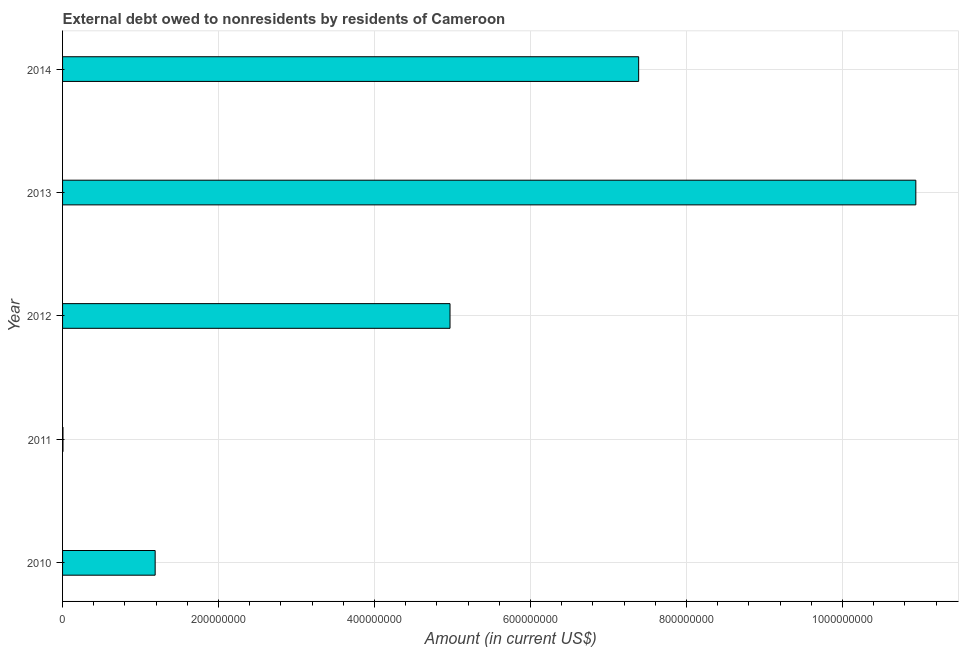Does the graph contain any zero values?
Keep it short and to the point. No. Does the graph contain grids?
Your response must be concise. Yes. What is the title of the graph?
Your answer should be very brief. External debt owed to nonresidents by residents of Cameroon. What is the label or title of the X-axis?
Provide a succinct answer. Amount (in current US$). What is the label or title of the Y-axis?
Your answer should be compact. Year. What is the debt in 2011?
Your answer should be compact. 5.33e+05. Across all years, what is the maximum debt?
Offer a terse response. 1.09e+09. Across all years, what is the minimum debt?
Your response must be concise. 5.33e+05. In which year was the debt maximum?
Keep it short and to the point. 2013. What is the sum of the debt?
Keep it short and to the point. 2.45e+09. What is the difference between the debt in 2011 and 2012?
Your response must be concise. -4.96e+08. What is the average debt per year?
Ensure brevity in your answer.  4.90e+08. What is the median debt?
Provide a short and direct response. 4.97e+08. What is the ratio of the debt in 2010 to that in 2014?
Keep it short and to the point. 0.16. Is the debt in 2010 less than that in 2011?
Your answer should be very brief. No. What is the difference between the highest and the second highest debt?
Offer a terse response. 3.55e+08. Is the sum of the debt in 2013 and 2014 greater than the maximum debt across all years?
Your answer should be compact. Yes. What is the difference between the highest and the lowest debt?
Offer a very short reply. 1.09e+09. How many bars are there?
Provide a short and direct response. 5. Are all the bars in the graph horizontal?
Provide a succinct answer. Yes. How many years are there in the graph?
Make the answer very short. 5. Are the values on the major ticks of X-axis written in scientific E-notation?
Keep it short and to the point. No. What is the Amount (in current US$) in 2010?
Give a very brief answer. 1.19e+08. What is the Amount (in current US$) of 2011?
Keep it short and to the point. 5.33e+05. What is the Amount (in current US$) of 2012?
Offer a terse response. 4.97e+08. What is the Amount (in current US$) in 2013?
Offer a very short reply. 1.09e+09. What is the Amount (in current US$) of 2014?
Provide a short and direct response. 7.39e+08. What is the difference between the Amount (in current US$) in 2010 and 2011?
Provide a short and direct response. 1.18e+08. What is the difference between the Amount (in current US$) in 2010 and 2012?
Offer a very short reply. -3.78e+08. What is the difference between the Amount (in current US$) in 2010 and 2013?
Your response must be concise. -9.75e+08. What is the difference between the Amount (in current US$) in 2010 and 2014?
Make the answer very short. -6.20e+08. What is the difference between the Amount (in current US$) in 2011 and 2012?
Provide a short and direct response. -4.96e+08. What is the difference between the Amount (in current US$) in 2011 and 2013?
Your response must be concise. -1.09e+09. What is the difference between the Amount (in current US$) in 2011 and 2014?
Your answer should be very brief. -7.38e+08. What is the difference between the Amount (in current US$) in 2012 and 2013?
Your answer should be compact. -5.97e+08. What is the difference between the Amount (in current US$) in 2012 and 2014?
Provide a short and direct response. -2.42e+08. What is the difference between the Amount (in current US$) in 2013 and 2014?
Offer a very short reply. 3.55e+08. What is the ratio of the Amount (in current US$) in 2010 to that in 2011?
Offer a very short reply. 222.72. What is the ratio of the Amount (in current US$) in 2010 to that in 2012?
Your answer should be compact. 0.24. What is the ratio of the Amount (in current US$) in 2010 to that in 2013?
Provide a succinct answer. 0.11. What is the ratio of the Amount (in current US$) in 2010 to that in 2014?
Your answer should be compact. 0.16. What is the ratio of the Amount (in current US$) in 2011 to that in 2013?
Your answer should be compact. 0. What is the ratio of the Amount (in current US$) in 2012 to that in 2013?
Your answer should be compact. 0.45. What is the ratio of the Amount (in current US$) in 2012 to that in 2014?
Provide a short and direct response. 0.67. What is the ratio of the Amount (in current US$) in 2013 to that in 2014?
Give a very brief answer. 1.48. 